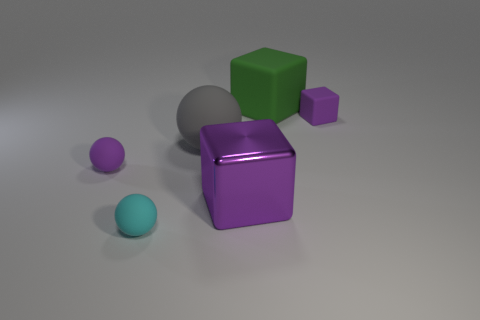What number of matte things are left of the small block and on the right side of the large rubber cube?
Provide a succinct answer. 0. What is the big green block made of?
Ensure brevity in your answer.  Rubber. Are there an equal number of big spheres that are on the right side of the purple shiny cube and gray blocks?
Make the answer very short. Yes. What number of other rubber things are the same shape as the green matte thing?
Offer a terse response. 1. Is the big purple object the same shape as the small cyan matte object?
Your answer should be very brief. No. How many things are either cubes on the left side of the tiny purple cube or small purple objects?
Offer a terse response. 4. What shape is the small purple matte thing right of the rubber object in front of the cube that is on the left side of the large green thing?
Offer a very short reply. Cube. The small purple thing that is made of the same material as the tiny purple ball is what shape?
Keep it short and to the point. Cube. What size is the purple rubber sphere?
Make the answer very short. Small. Is the size of the green rubber object the same as the cyan ball?
Your response must be concise. No. 